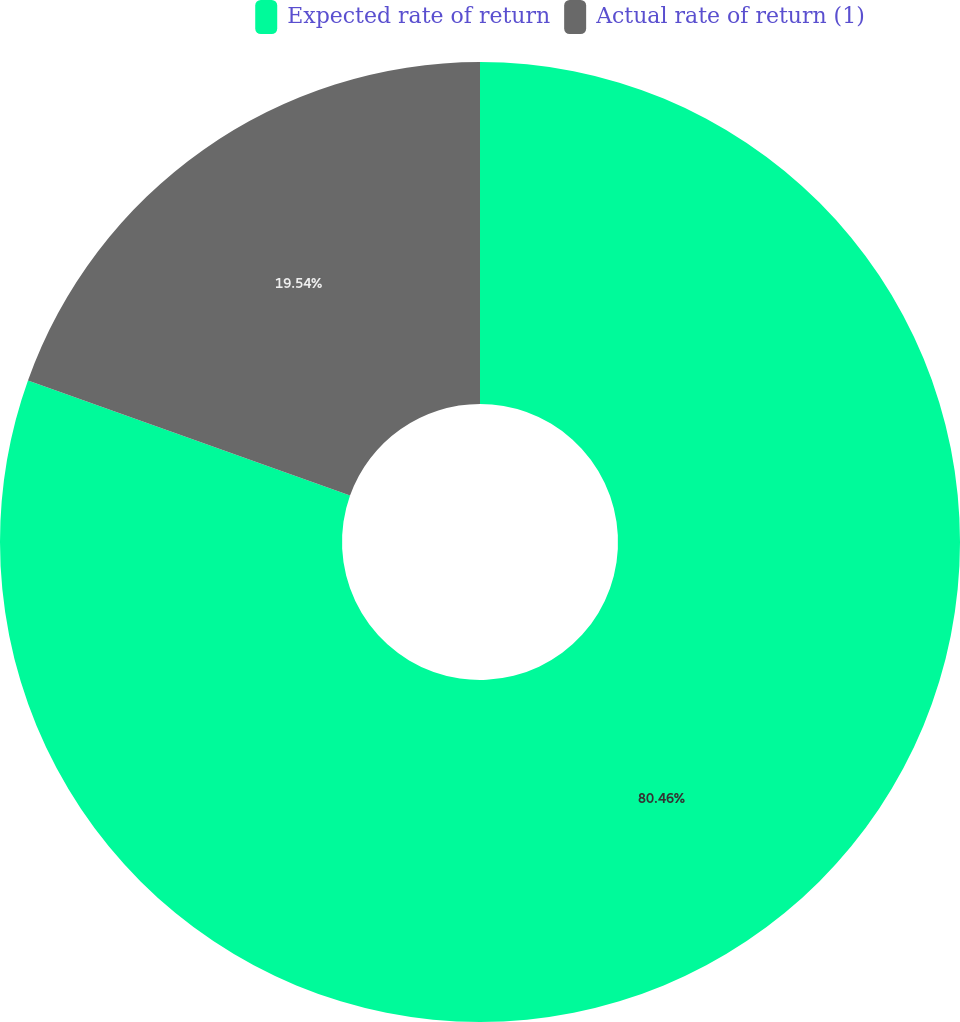Convert chart. <chart><loc_0><loc_0><loc_500><loc_500><pie_chart><fcel>Expected rate of return<fcel>Actual rate of return (1)<nl><fcel>80.46%<fcel>19.54%<nl></chart> 